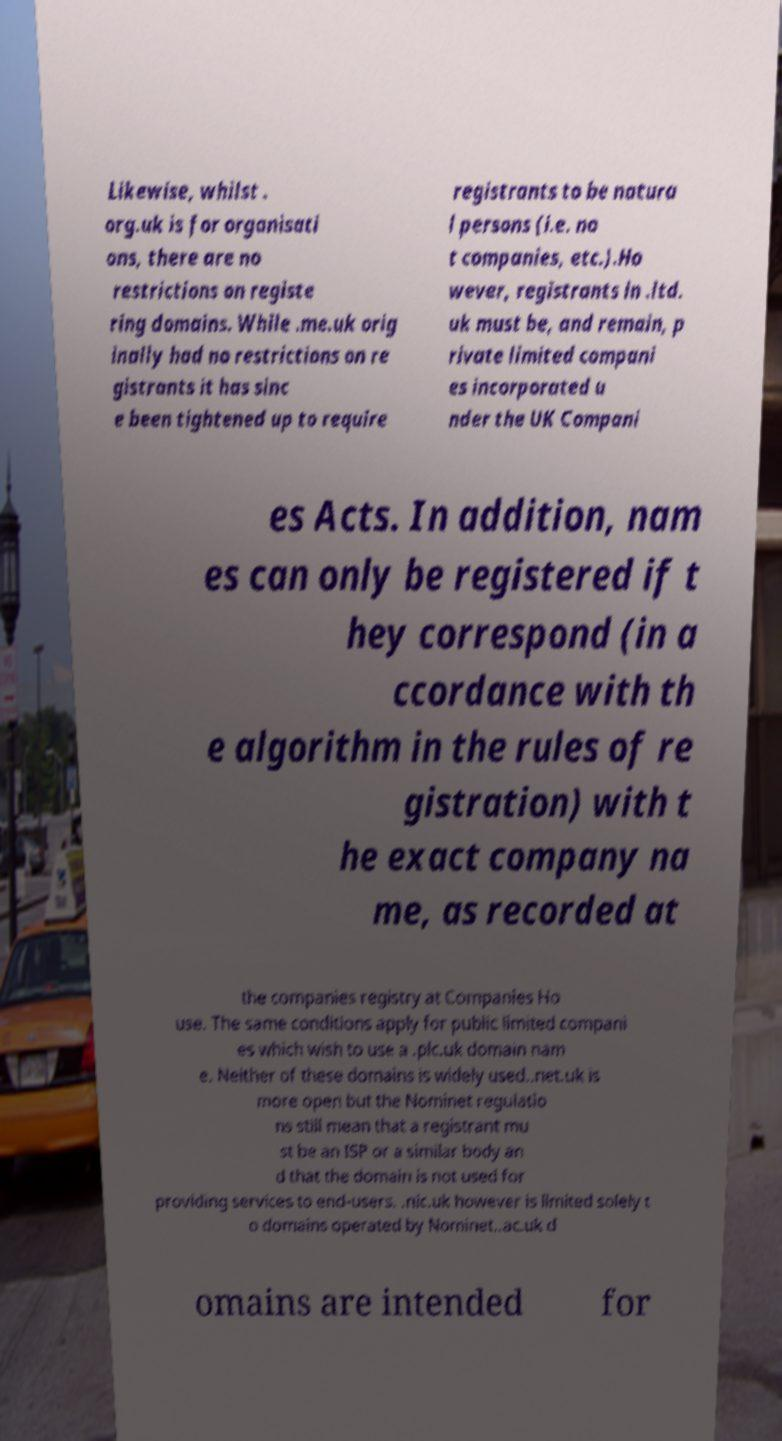Please read and relay the text visible in this image. What does it say? Likewise, whilst . org.uk is for organisati ons, there are no restrictions on registe ring domains. While .me.uk orig inally had no restrictions on re gistrants it has sinc e been tightened up to require registrants to be natura l persons (i.e. no t companies, etc.).Ho wever, registrants in .ltd. uk must be, and remain, p rivate limited compani es incorporated u nder the UK Compani es Acts. In addition, nam es can only be registered if t hey correspond (in a ccordance with th e algorithm in the rules of re gistration) with t he exact company na me, as recorded at the companies registry at Companies Ho use. The same conditions apply for public limited compani es which wish to use a .plc.uk domain nam e. Neither of these domains is widely used..net.uk is more open but the Nominet regulatio ns still mean that a registrant mu st be an ISP or a similar body an d that the domain is not used for providing services to end-users. .nic.uk however is limited solely t o domains operated by Nominet..ac.uk d omains are intended for 